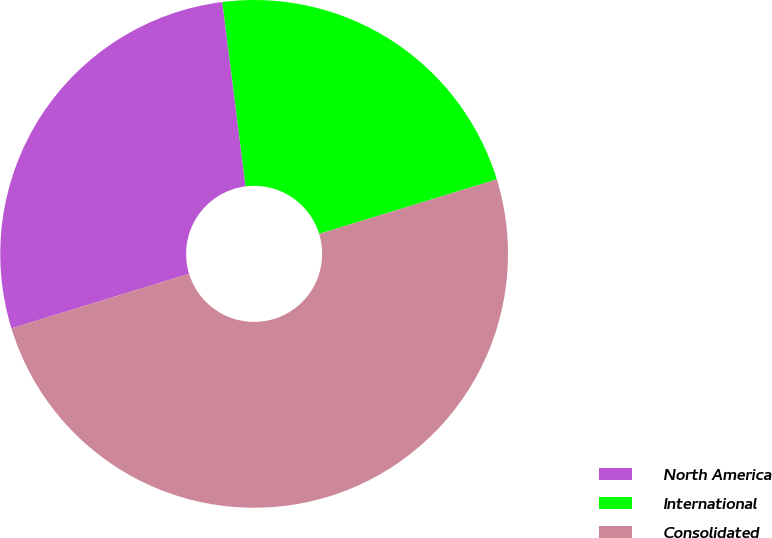Convert chart to OTSL. <chart><loc_0><loc_0><loc_500><loc_500><pie_chart><fcel>North America<fcel>International<fcel>Consolidated<nl><fcel>27.74%<fcel>22.26%<fcel>50.0%<nl></chart> 